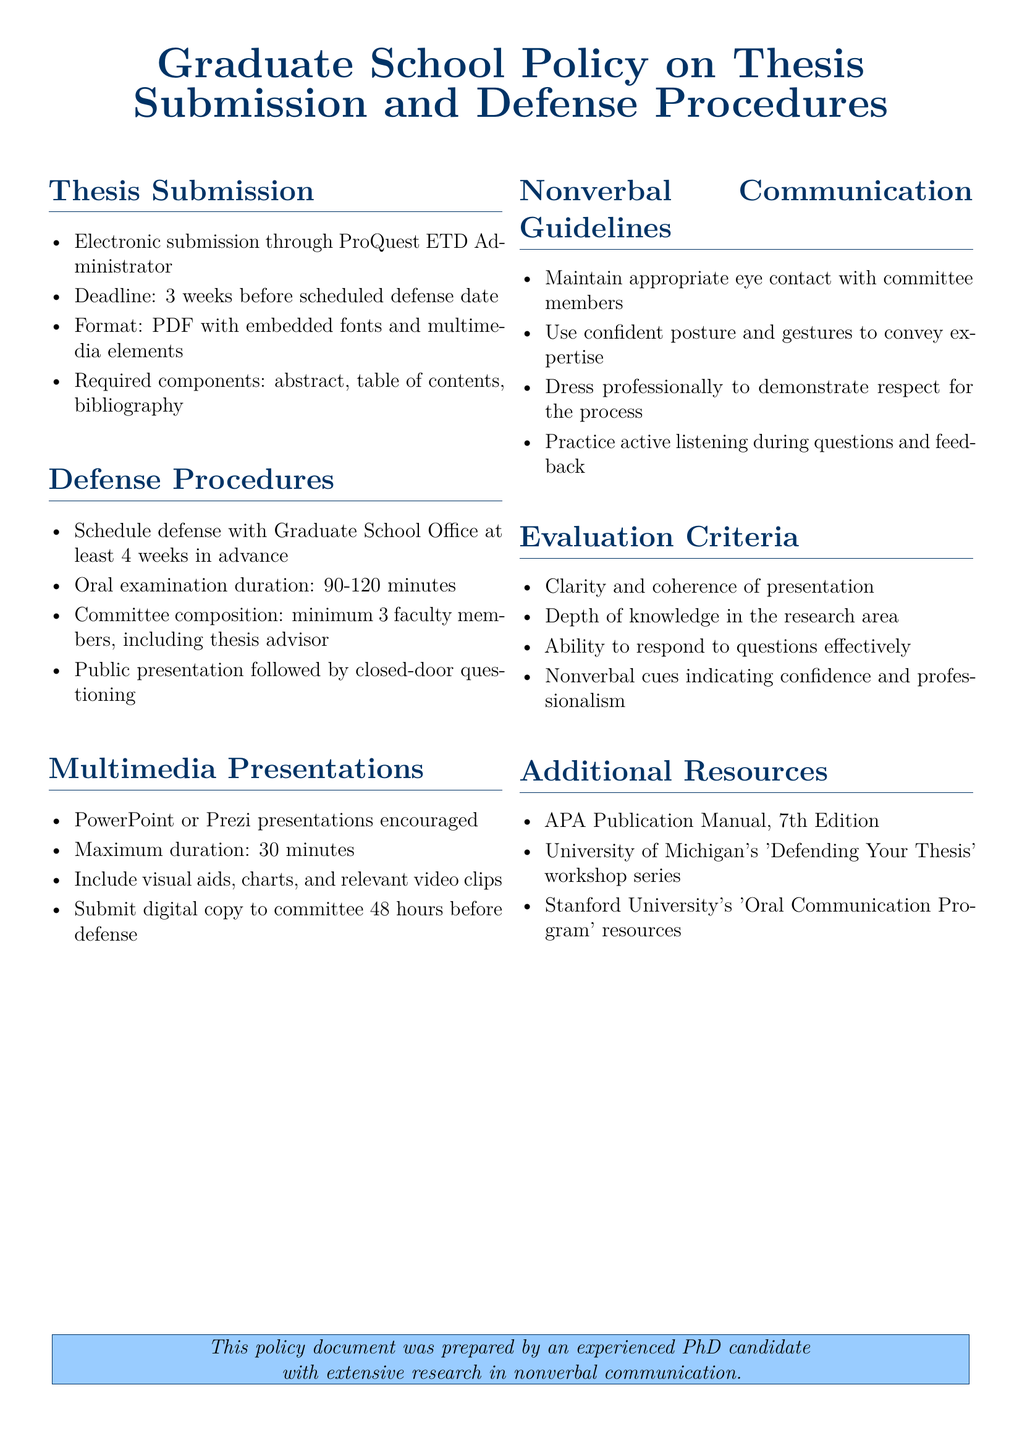What is the deadline for thesis submission? The deadline for thesis submission is specified to be 3 weeks before the scheduled defense date.
Answer: 3 weeks How many faculty members are required in the thesis committee? The document states that a minimum of 3 faculty members is required, including the thesis advisor.
Answer: 3 What is the maximum duration for the multimedia presentation? The maximum duration for the multimedia presentation is specifically mentioned in the document.
Answer: 30 minutes What is one guideline for nonverbal communication? The document outlines several guidelines; one of them is maintaining appropriate eye contact with committee members.
Answer: Eye contact What is the electronic submission platform for the thesis? The policy document indicates that electronic submission should be done through ProQuest ETD Administrator.
Answer: ProQuest ETD Administrator How long is the duration of the oral examination? The oral examination duration is clearly stated in the document, providing a range.
Answer: 90-120 minutes What should be submitted to the committee 48 hours before the defense? The document specifies that a digital copy of the multimedia presentation must be submitted to the committee.
Answer: Digital copy What type of dress is recommended for the defense? The guidelines in the document suggest dressing in a specific manner to demonstrate respect for the process.
Answer: Professionally What resource is suggested for thesis defense preparation? The document lists several resources; one of them is the 'Defending Your Thesis' workshop series at the University of Michigan.
Answer: 'Defending Your Thesis' workshop series 